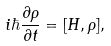Convert formula to latex. <formula><loc_0><loc_0><loc_500><loc_500>i \hbar { \frac { \partial \rho } { \partial t } } = [ H , \rho ] ,</formula> 